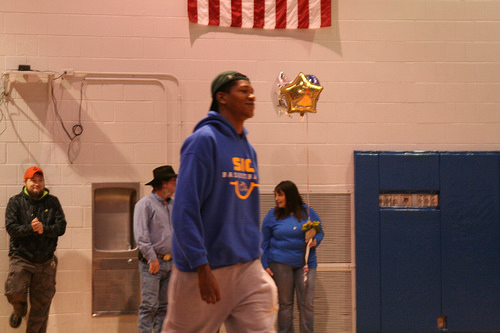<image>
Is there a man to the left of the man? Yes. From this viewpoint, the man is positioned to the left side relative to the man. 